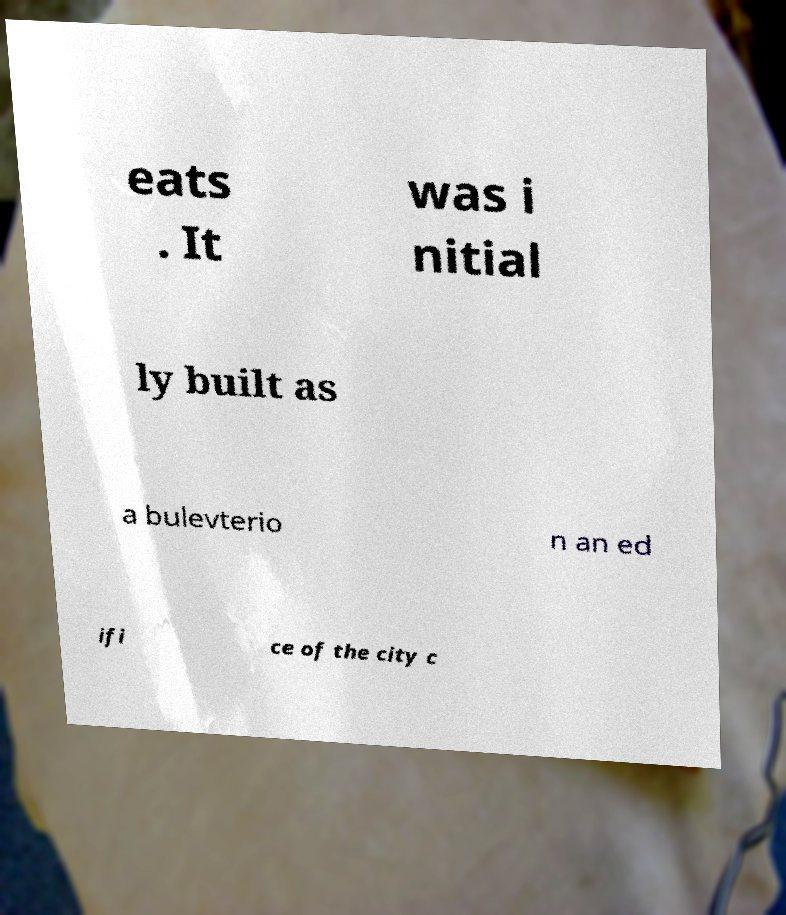Can you accurately transcribe the text from the provided image for me? eats . It was i nitial ly built as a bulevterio n an ed ifi ce of the city c 